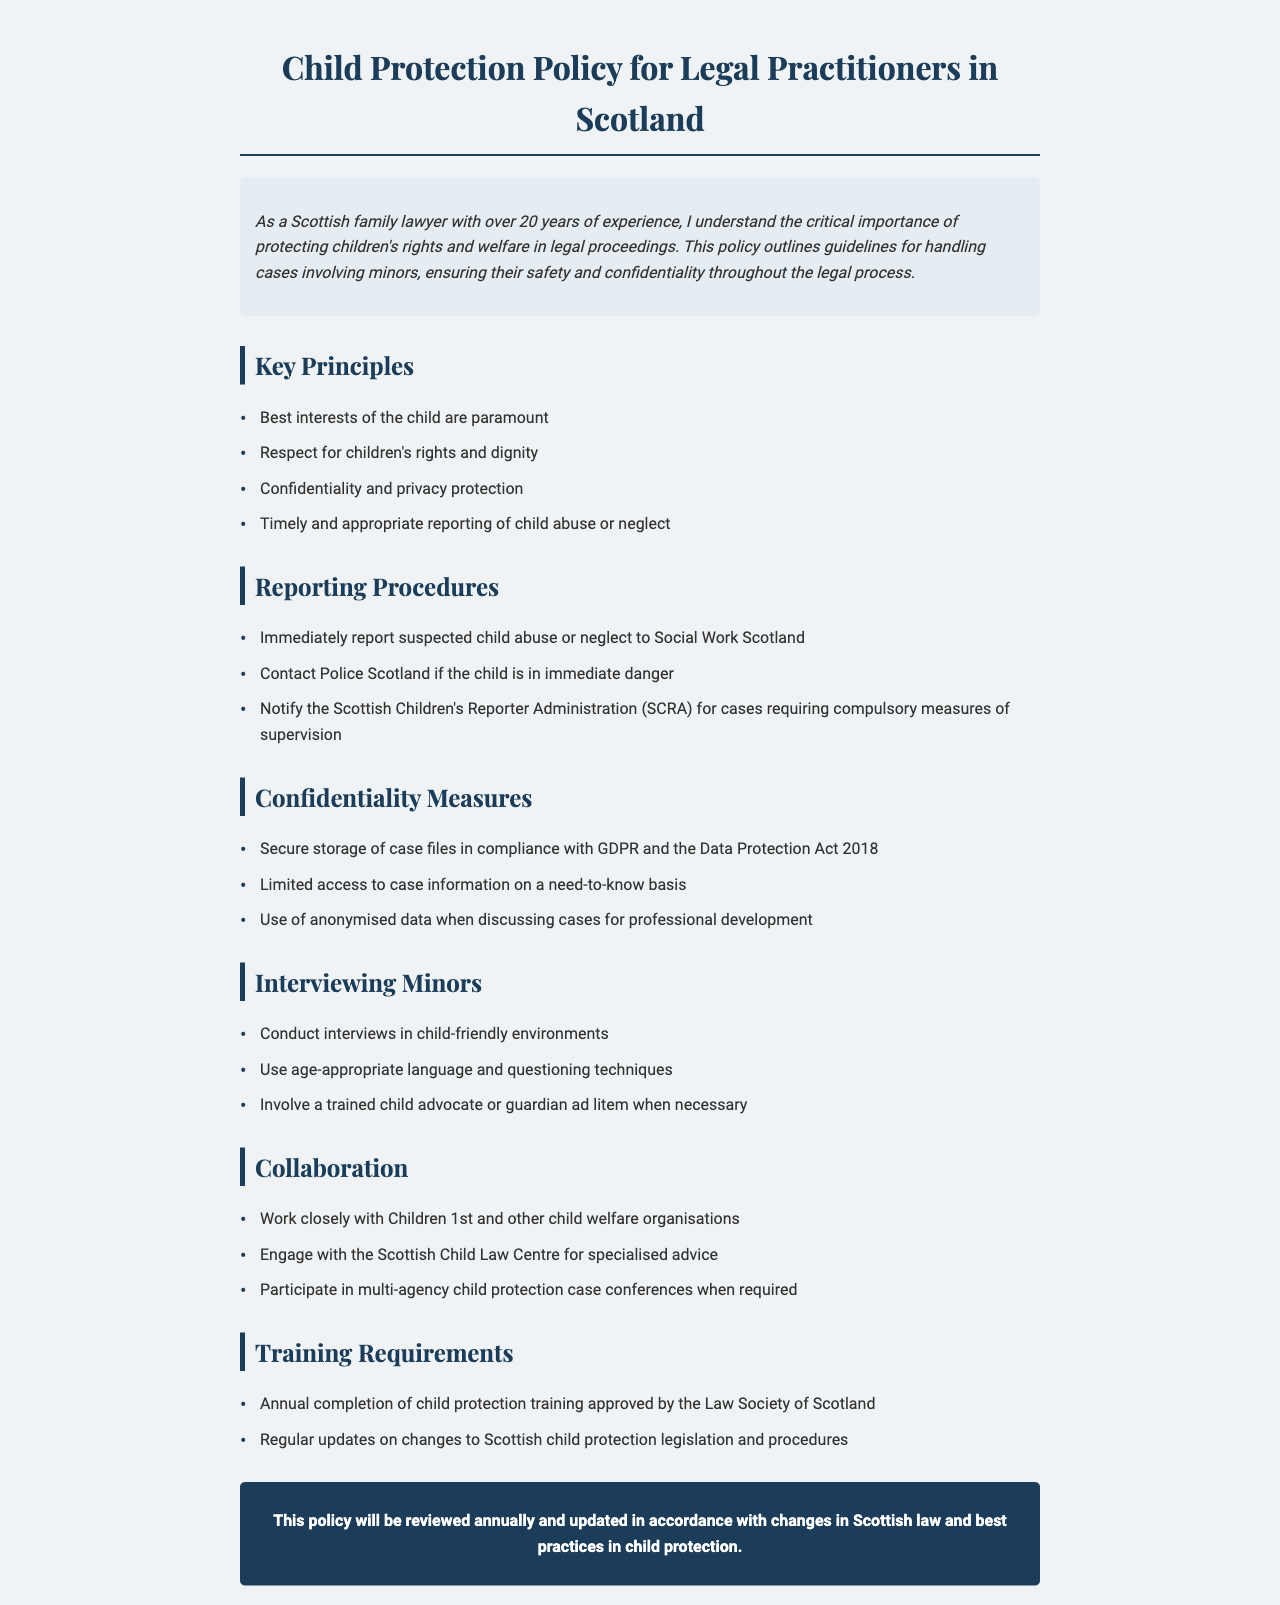what is the title of the policy document? The title of the document is located at the top, which states "Child Protection Policy for Legal Practitioners in Scotland."
Answer: Child Protection Policy for Legal Practitioners in Scotland what are the key principles of the policy? The key principles are listed under a specific section, highlighting the major tenets included in the policy.
Answer: Best interests of the child are paramount, Respect for children's rights and dignity, Confidentiality and privacy protection, Timely and appropriate reporting of child abuse or neglect who should be contacted if a child is in immediate danger? The document specifies that Police Scotland should be contacted in case of immediate danger to a child.
Answer: Police Scotland what type of training is required annually? The document indicates that practitioners must complete child protection training approved by the Law Society of Scotland annually.
Answer: Child protection training approved by the Law Society of Scotland what is the frequency of the policy review? Information about the policy review process is mentioned, stating a specific interval for when the document is reviewed.
Answer: Annually what is the role of the Scottish Children's Reporter Administration (SCRA)? The document describes the function of SCRA in cases requiring compulsory measures of supervision.
Answer: Compulsory measures of supervision how should interviews with minors be conducted? The document provides guidelines regarding the environment and techniques to use when interviewing minors.
Answer: In child-friendly environments what measures are recommended for confidentiality? The document outlines specific actions to ensure confidentiality in handling cases involving minors.
Answer: Secure storage of case files in compliance with GDPR and the Data Protection Act 2018 who should be involved when necessary during interviews with minors? The policy suggests that involvement of specific trained individuals may be important during interviews with minors.
Answer: A trained child advocate or guardian ad litem 